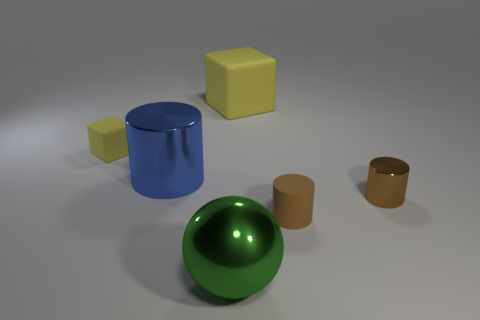There is a yellow cube that is on the left side of the green object; is its size the same as the yellow thing that is on the right side of the small yellow matte object?
Provide a short and direct response. No. The brown thing that is the same material as the blue thing is what size?
Ensure brevity in your answer.  Small. Does the matte cube to the right of the large sphere have the same color as the cube that is left of the blue metallic cylinder?
Provide a succinct answer. Yes. What shape is the big thing behind the yellow rubber block to the left of the big cylinder?
Offer a terse response. Cube. Are there any green shiny blocks of the same size as the blue object?
Offer a terse response. No. How many tiny yellow rubber objects are the same shape as the big yellow thing?
Ensure brevity in your answer.  1. Are there the same number of big blue metallic objects that are behind the shiny ball and objects right of the brown metallic cylinder?
Your response must be concise. No. Are any blue matte cylinders visible?
Ensure brevity in your answer.  No. There is a metal thing that is in front of the small matte object that is in front of the yellow rubber block in front of the large yellow block; how big is it?
Your answer should be very brief. Large. The green thing that is the same size as the blue shiny cylinder is what shape?
Make the answer very short. Sphere. 